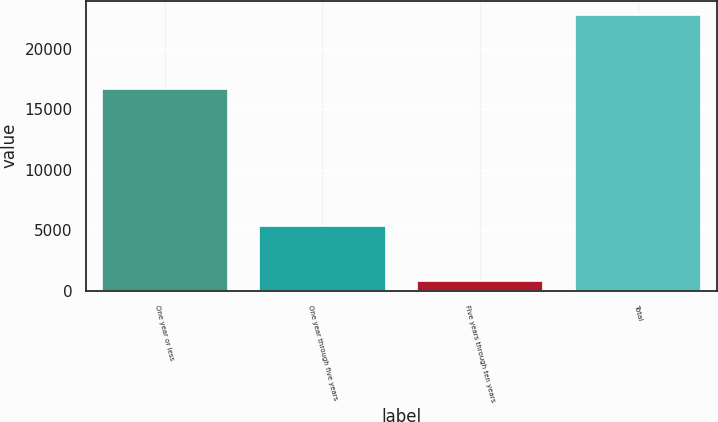Convert chart to OTSL. <chart><loc_0><loc_0><loc_500><loc_500><bar_chart><fcel>One year or less<fcel>One year through five years<fcel>Five years through ten years<fcel>Total<nl><fcel>16681<fcel>5310<fcel>830<fcel>22821<nl></chart> 